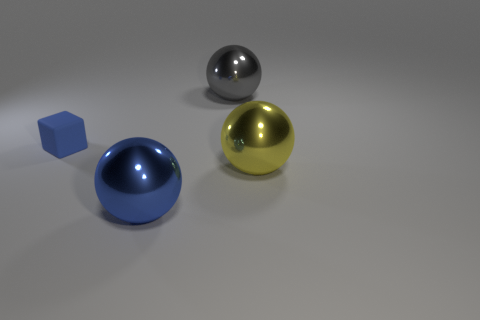Subtract all large gray balls. How many balls are left? 2 Add 1 yellow shiny spheres. How many objects exist? 5 Subtract all blocks. How many objects are left? 3 Subtract all gray spheres. Subtract all gray cylinders. How many spheres are left? 2 Subtract all tiny blue things. Subtract all rubber things. How many objects are left? 2 Add 1 tiny blue things. How many tiny blue things are left? 2 Add 1 big gray things. How many big gray things exist? 2 Subtract 0 green cylinders. How many objects are left? 4 